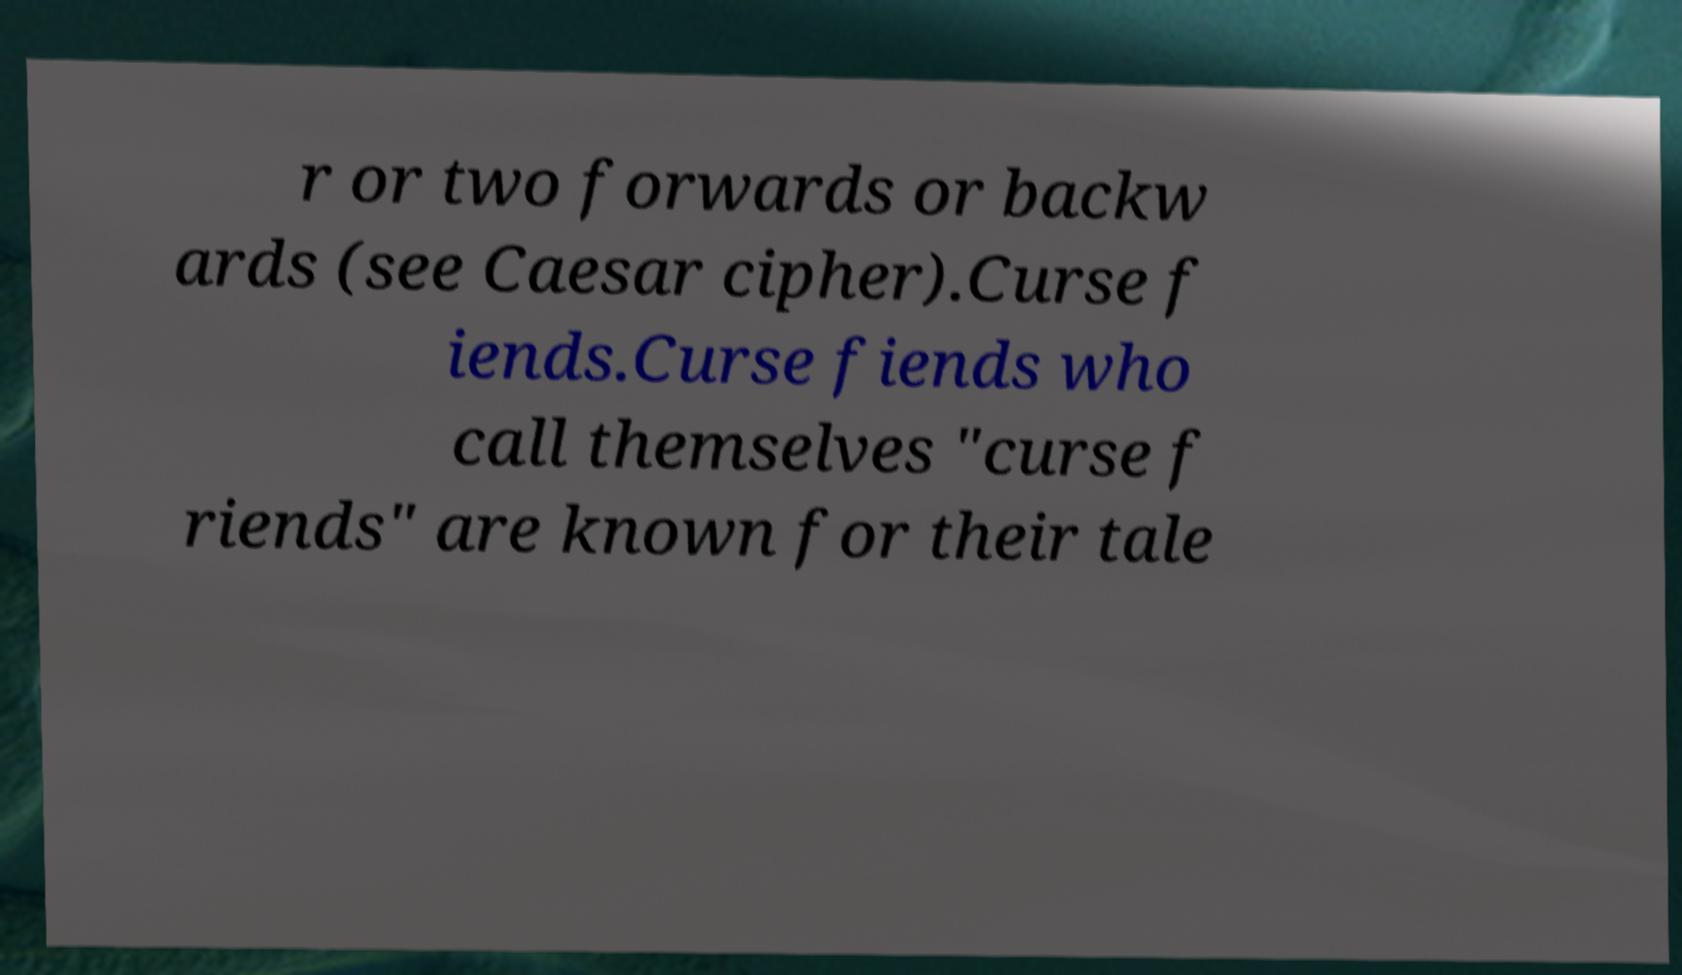For documentation purposes, I need the text within this image transcribed. Could you provide that? r or two forwards or backw ards (see Caesar cipher).Curse f iends.Curse fiends who call themselves "curse f riends" are known for their tale 